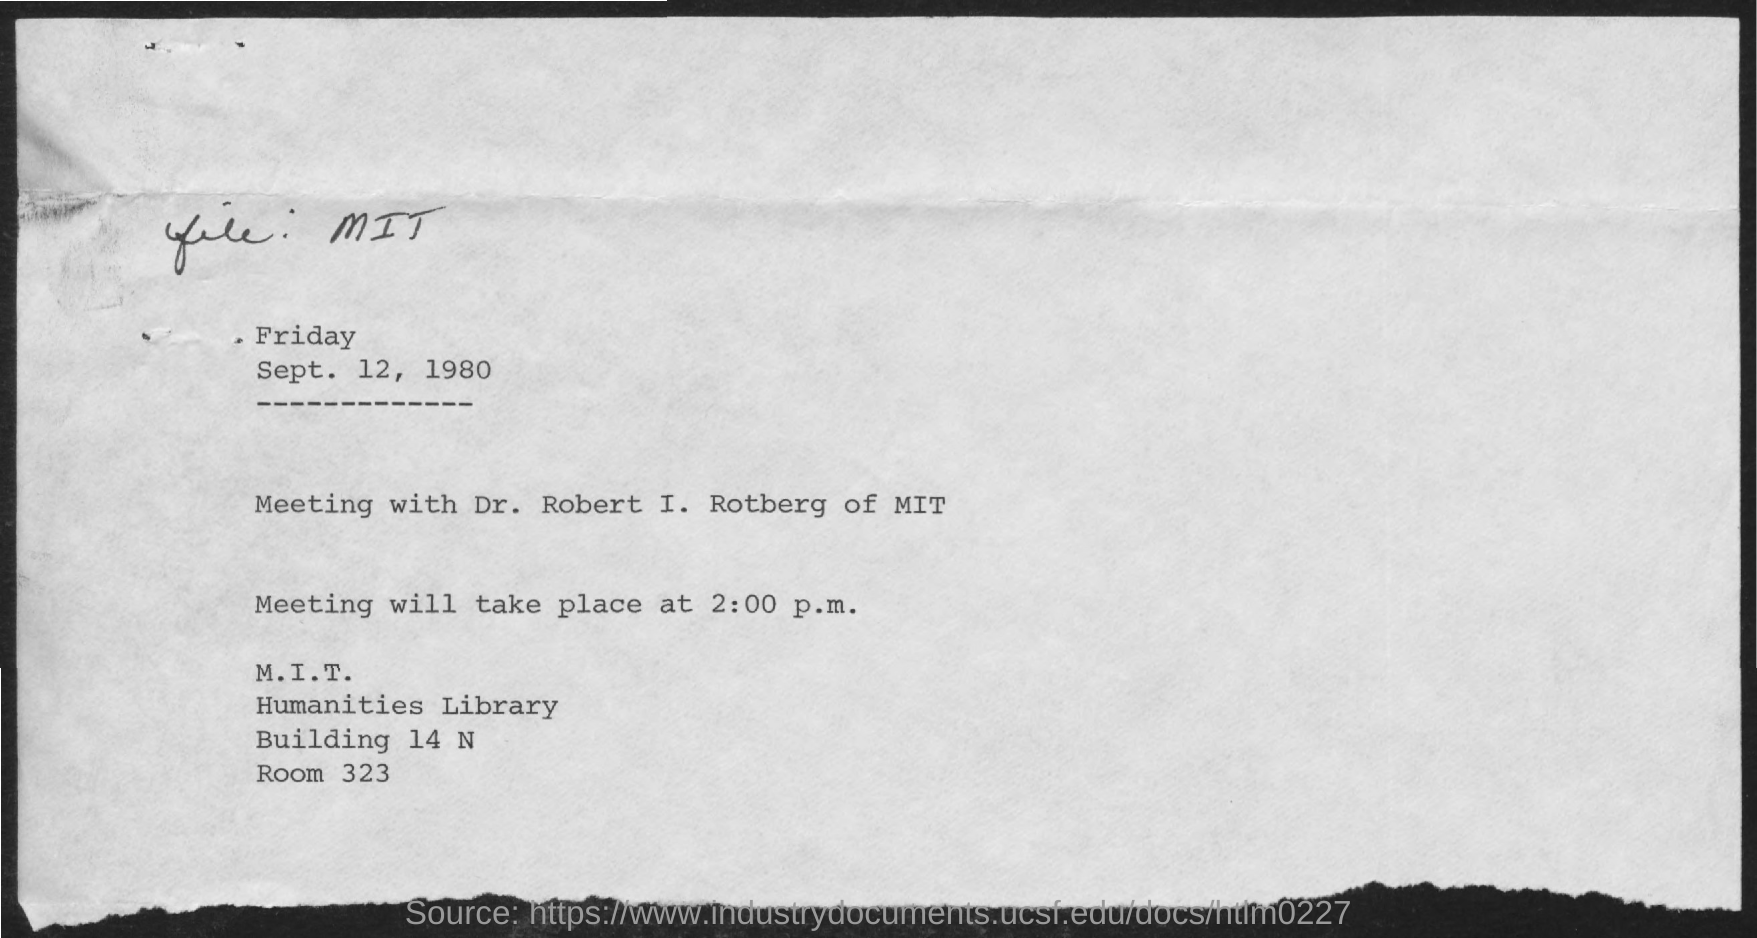What is the date on the document?
Provide a succinct answer. Sept. 12, 1980. The meeting is with whom?
Provide a succinct answer. Dr. robert i. rotberg of mit. When will the meeting take place?
Make the answer very short. 2:00 p.m. 